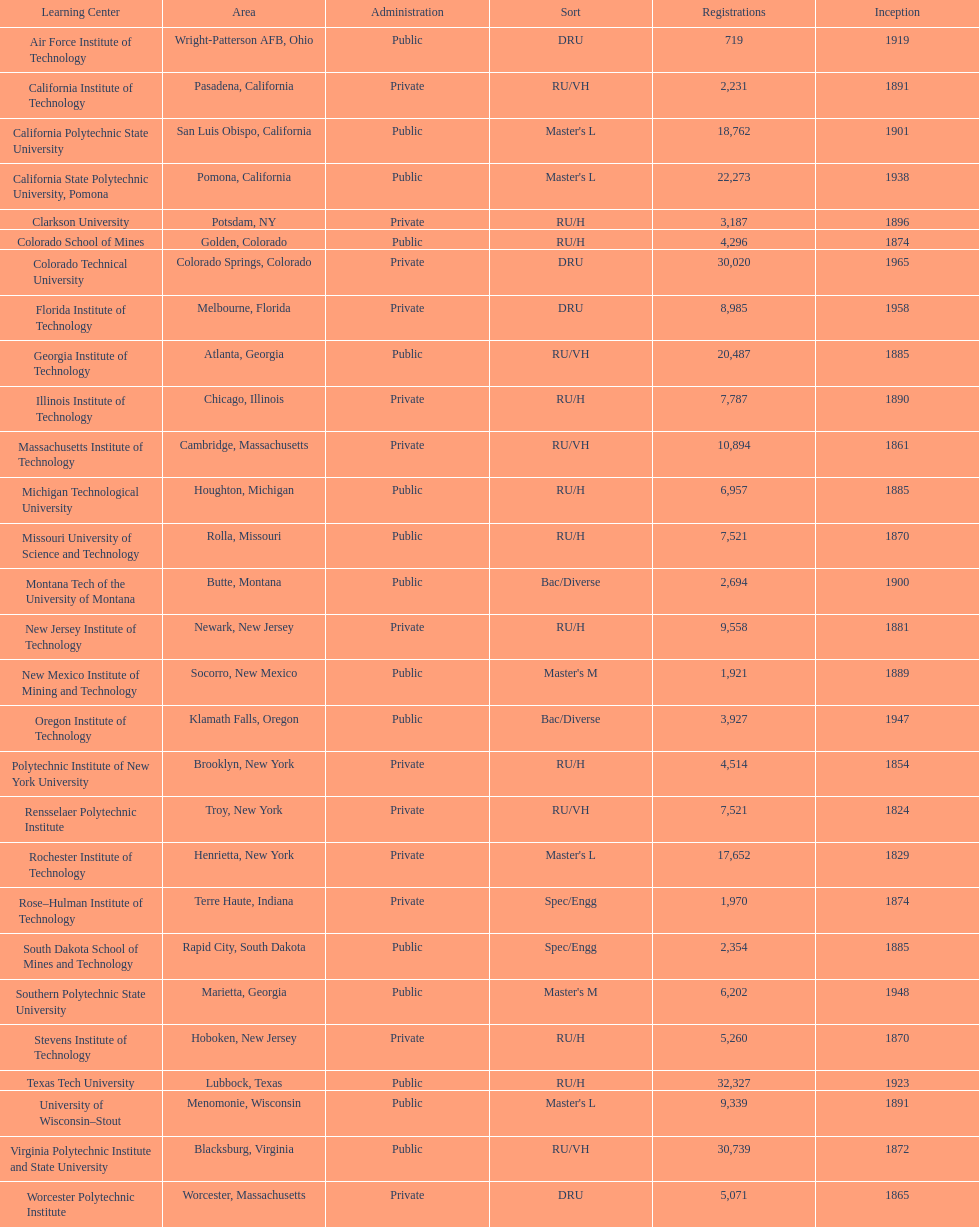What is the number of us technological schools in the state of california? 3. 